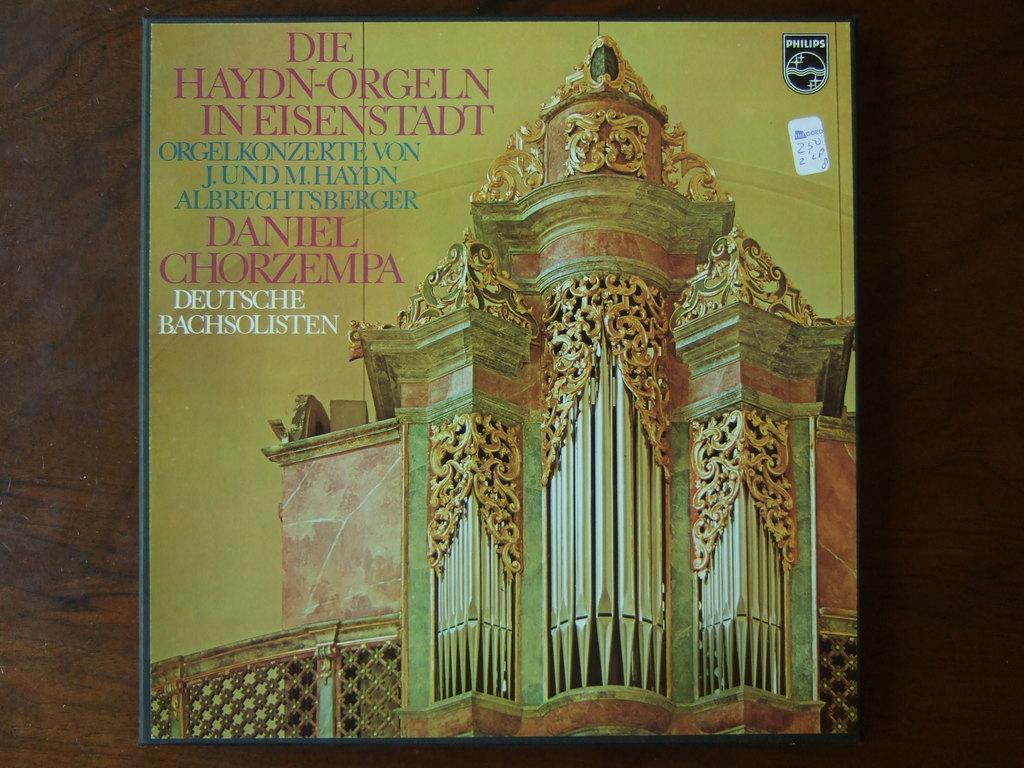In one or two sentences, can you explain what this image depicts? In this image we can see a poster with text and image. 